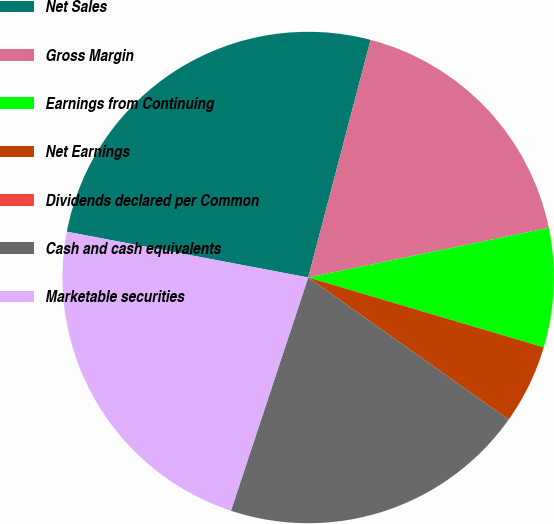Convert chart. <chart><loc_0><loc_0><loc_500><loc_500><pie_chart><fcel>Net Sales<fcel>Gross Margin<fcel>Earnings from Continuing<fcel>Net Earnings<fcel>Dividends declared per Common<fcel>Cash and cash equivalents<fcel>Marketable securities<nl><fcel>26.1%<fcel>17.67%<fcel>7.83%<fcel>5.22%<fcel>0.0%<fcel>20.28%<fcel>22.89%<nl></chart> 